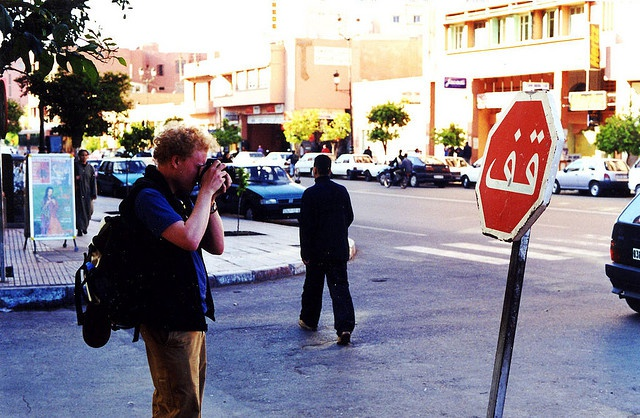Describe the objects in this image and their specific colors. I can see people in black, maroon, brown, and navy tones, people in black, gray, darkgray, and navy tones, stop sign in black, brown, ivory, and lightpink tones, backpack in black, navy, gray, and darkgray tones, and car in black, navy, white, and blue tones in this image. 